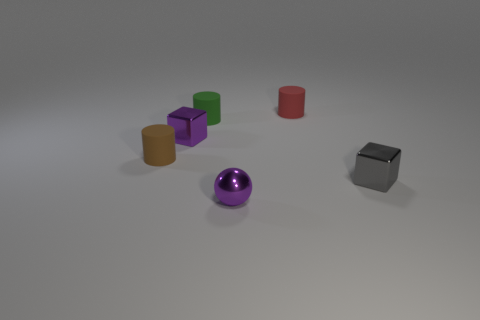Which objects in the image look the most similar in shape, and what are those shapes? The two cylindrical objects share the most similar shape, characterized by their round bases and uniform vertical sides, which classify them as cylinders. Can you guess the material the objects might be made of, based on their appearance? Based on their appearance, the objects exhibit a polished surface that suggests they might be made of a type of metal or plastic, likely chosen for their durability and sheen. 